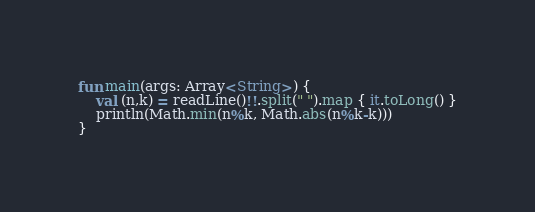<code> <loc_0><loc_0><loc_500><loc_500><_Kotlin_>fun main(args: Array<String>) {
    val (n,k) = readLine()!!.split(" ").map { it.toLong() }
    println(Math.min(n%k, Math.abs(n%k-k)))
}
</code> 